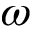Convert formula to latex. <formula><loc_0><loc_0><loc_500><loc_500>\omega</formula> 